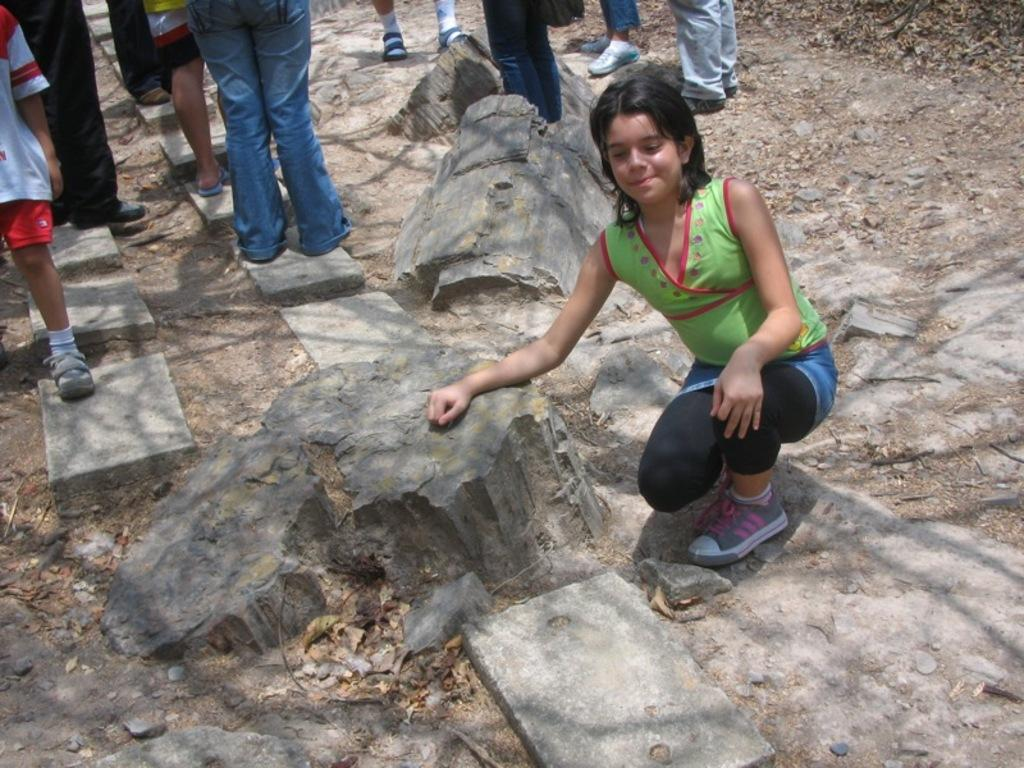Who is the main subject in the image? There is a girl in the image. What is the girl's expression in the image? The girl is smiling. What can be seen in the background of the image? There is a group of people standing and rocks are present in the background of the image. What is visible on the ground in the image? The ground is visible in the background of the image. What type of knowledge is the girl sharing with the group in the image? There is no indication in the image that the girl is sharing any knowledge with the group. What type of cloud can be seen in the image? There are no clouds visible in the image. 